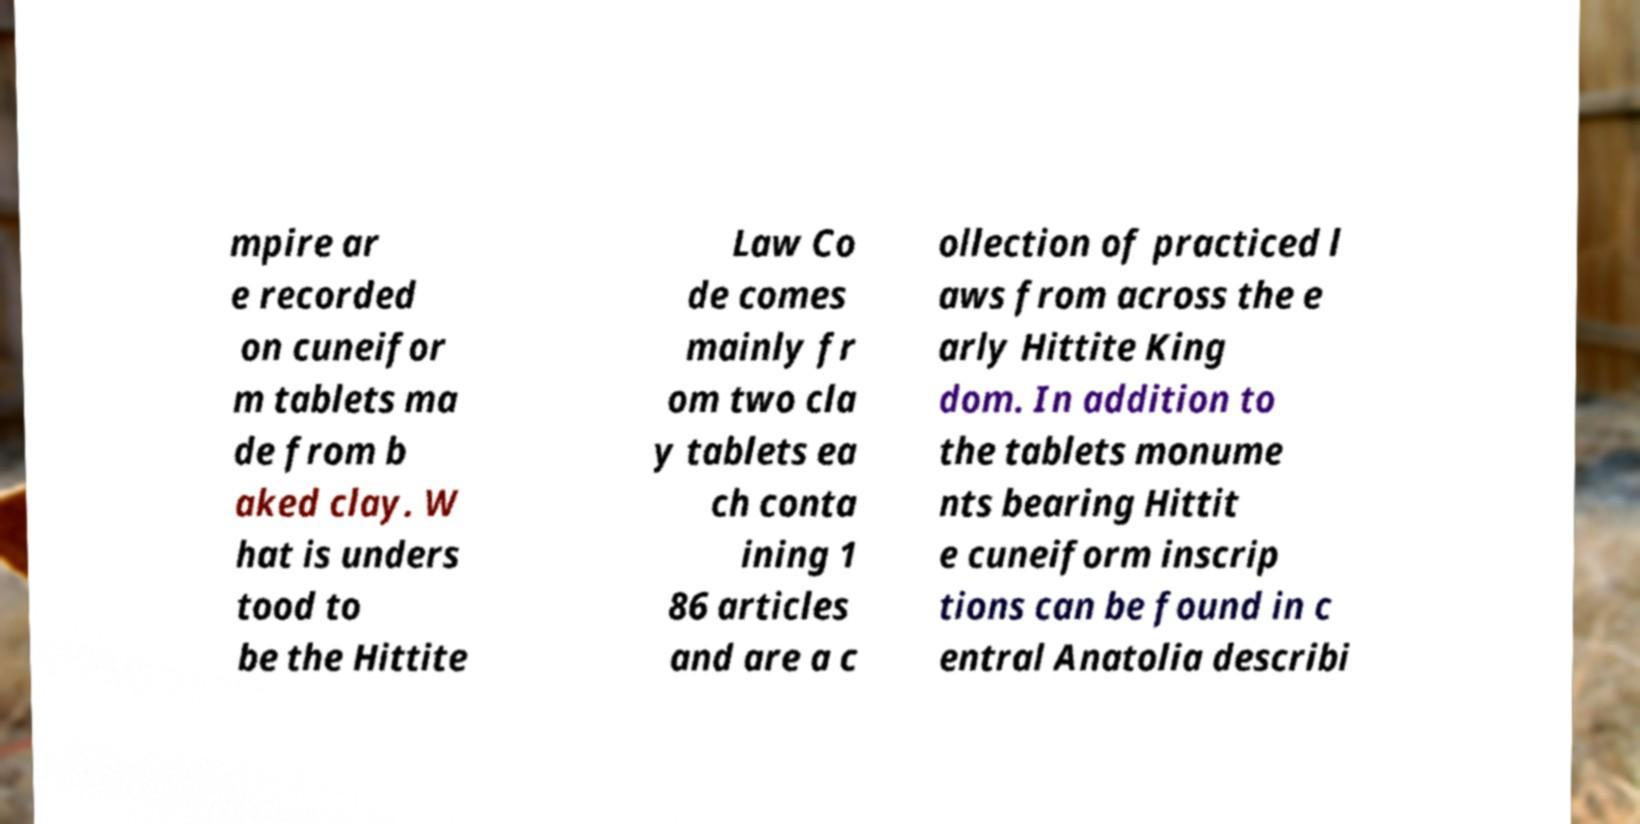For documentation purposes, I need the text within this image transcribed. Could you provide that? mpire ar e recorded on cuneifor m tablets ma de from b aked clay. W hat is unders tood to be the Hittite Law Co de comes mainly fr om two cla y tablets ea ch conta ining 1 86 articles and are a c ollection of practiced l aws from across the e arly Hittite King dom. In addition to the tablets monume nts bearing Hittit e cuneiform inscrip tions can be found in c entral Anatolia describi 